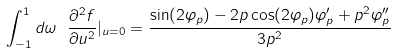Convert formula to latex. <formula><loc_0><loc_0><loc_500><loc_500>\int _ { - 1 } ^ { 1 } d \omega \ \frac { \partial ^ { 2 } f } { \partial u ^ { 2 } } | _ { u = 0 } = \frac { \sin ( 2 \varphi _ { p } ) - 2 p \cos ( 2 \varphi _ { p } ) \varphi ^ { \prime } _ { p } + p ^ { 2 } \varphi ^ { \prime \prime } _ { p } } { 3 p ^ { 2 } }</formula> 